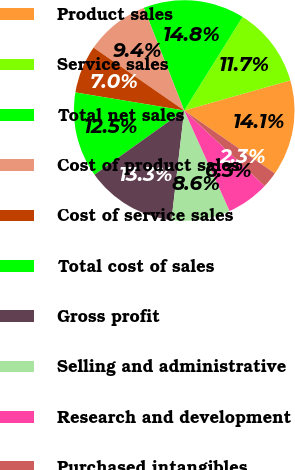<chart> <loc_0><loc_0><loc_500><loc_500><pie_chart><fcel>Product sales<fcel>Service sales<fcel>Total net sales<fcel>Cost of product sales<fcel>Cost of service sales<fcel>Total cost of sales<fcel>Gross profit<fcel>Selling and administrative<fcel>Research and development<fcel>Purchased intangibles<nl><fcel>14.06%<fcel>11.72%<fcel>14.84%<fcel>9.38%<fcel>7.03%<fcel>12.5%<fcel>13.28%<fcel>8.59%<fcel>6.25%<fcel>2.34%<nl></chart> 